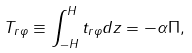Convert formula to latex. <formula><loc_0><loc_0><loc_500><loc_500>T _ { r \varphi } \equiv \int _ { - H } ^ { H } t _ { r \varphi } d z = - \alpha \Pi ,</formula> 